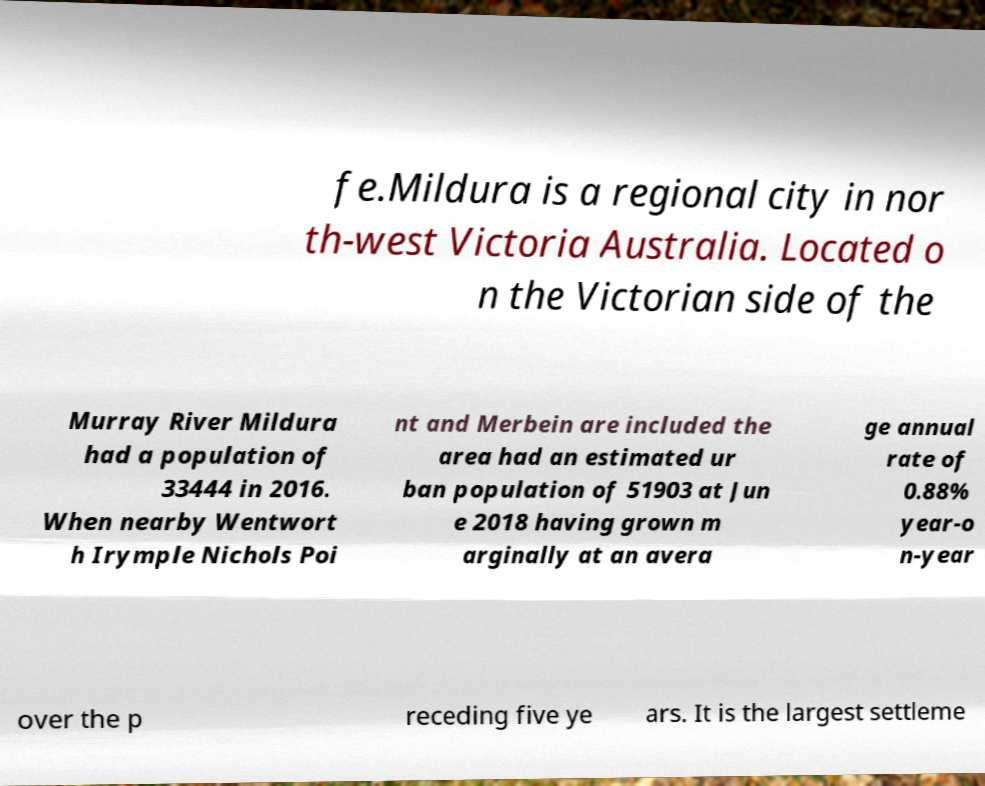What messages or text are displayed in this image? I need them in a readable, typed format. fe.Mildura is a regional city in nor th-west Victoria Australia. Located o n the Victorian side of the Murray River Mildura had a population of 33444 in 2016. When nearby Wentwort h Irymple Nichols Poi nt and Merbein are included the area had an estimated ur ban population of 51903 at Jun e 2018 having grown m arginally at an avera ge annual rate of 0.88% year-o n-year over the p receding five ye ars. It is the largest settleme 